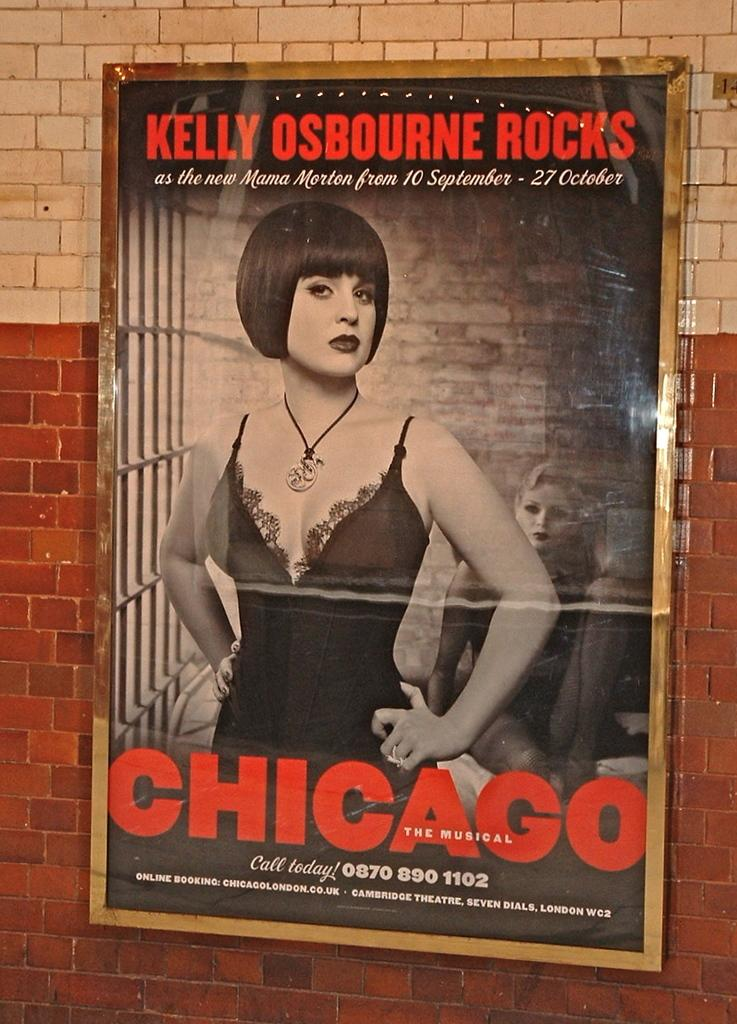<image>
Share a concise interpretation of the image provided. A poster ona brick wall advertising the musical Chicago with Kelly Osbourne. 